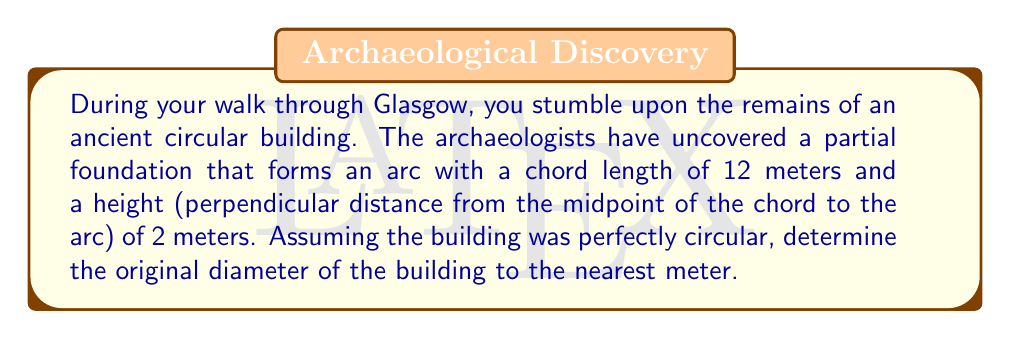Give your solution to this math problem. Let's approach this step-by-step using the properties of circles:

1) In a circle, we can use the equation relating the chord length (c), height (h), and diameter (d):

   $$ h = \frac{d}{2} - \sqrt{\frac{d^2}{4} - \frac{c^2}{4}} $$

2) We know that c = 12 meters and h = 2 meters. Let's substitute these values:

   $$ 2 = \frac{d}{2} - \sqrt{\frac{d^2}{4} - \frac{12^2}{4}} $$

3) Simplify:

   $$ 2 = \frac{d}{2} - \sqrt{\frac{d^2}{4} - 36} $$

4) Add $\frac{d}{2}$ to both sides:

   $$ 2 + \frac{d}{2} = \sqrt{\frac{d^2}{4} - 36} $$

5) Square both sides:

   $$ (2 + \frac{d}{2})^2 = \frac{d^2}{4} - 36 $$

6) Expand the left side:

   $$ 4 + 2d + \frac{d^2}{4} = \frac{d^2}{4} - 36 $$

7) Subtract $\frac{d^2}{4}$ from both sides:

   $$ 4 + 2d = -36 $$

8) Add 36 to both sides:

   $$ 40 + 2d = 0 $$

9) Subtract 40 from both sides:

   $$ 2d = -40 $$

10) Divide by 2:

    $$ d = -20 $$

11) Since diameter can't be negative, we take the absolute value:

    $$ d = 20 $$

Therefore, the original diameter of the building was 20 meters.
Answer: 20 meters 